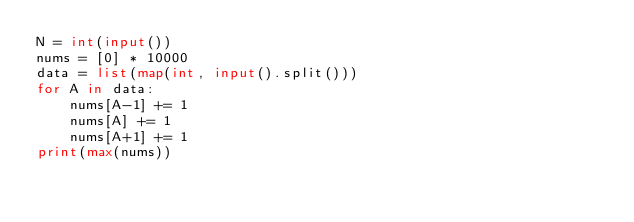Convert code to text. <code><loc_0><loc_0><loc_500><loc_500><_Python_>N = int(input())
nums = [0] * 10000
data = list(map(int, input().split()))
for A in data:
    nums[A-1] += 1
    nums[A] += 1
    nums[A+1] += 1
print(max(nums))
</code> 